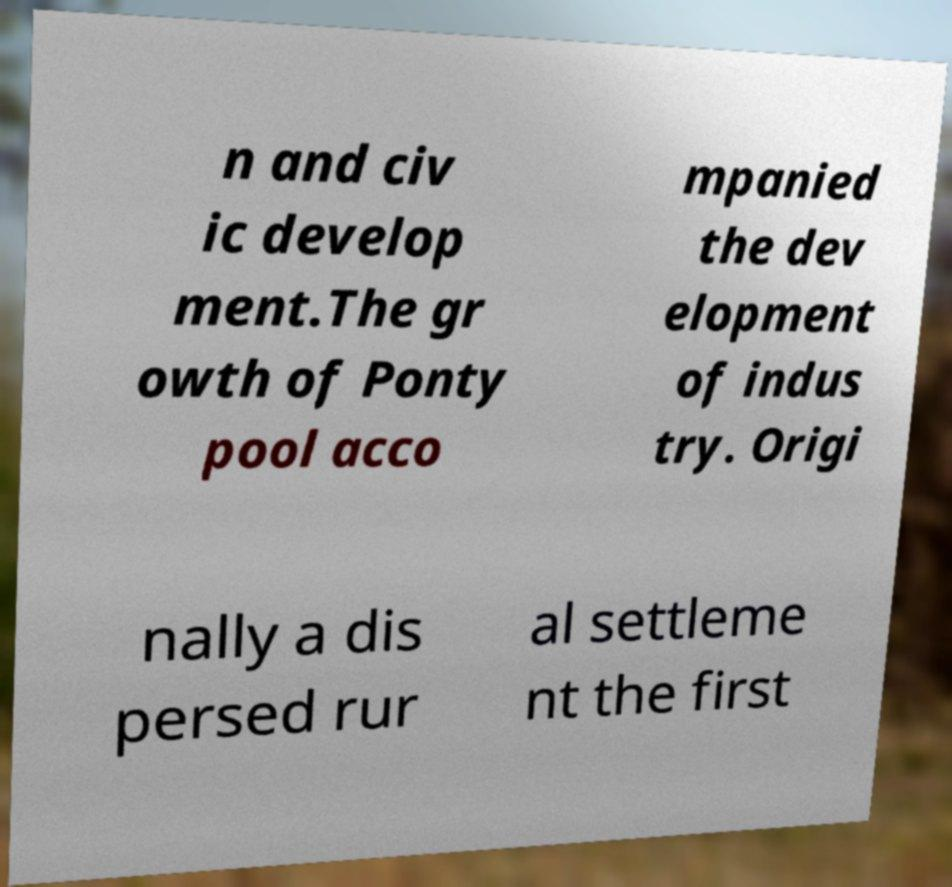Please identify and transcribe the text found in this image. n and civ ic develop ment.The gr owth of Ponty pool acco mpanied the dev elopment of indus try. Origi nally a dis persed rur al settleme nt the first 